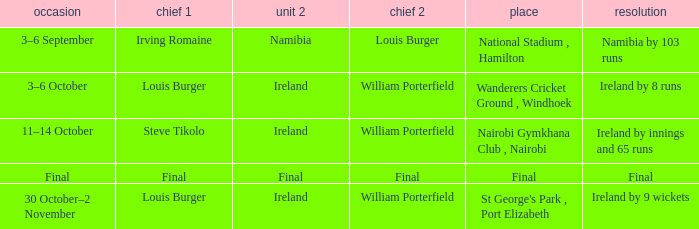Which Result has a Captain 2 of louis burger? Namibia by 103 runs. Could you help me parse every detail presented in this table? {'header': ['occasion', 'chief 1', 'unit 2', 'chief 2', 'place', 'resolution'], 'rows': [['3–6 September', 'Irving Romaine', 'Namibia', 'Louis Burger', 'National Stadium , Hamilton', 'Namibia by 103 runs'], ['3–6 October', 'Louis Burger', 'Ireland', 'William Porterfield', 'Wanderers Cricket Ground , Windhoek', 'Ireland by 8 runs'], ['11–14 October', 'Steve Tikolo', 'Ireland', 'William Porterfield', 'Nairobi Gymkhana Club , Nairobi', 'Ireland by innings and 65 runs'], ['Final', 'Final', 'Final', 'Final', 'Final', 'Final'], ['30 October–2 November', 'Louis Burger', 'Ireland', 'William Porterfield', "St George's Park , Port Elizabeth", 'Ireland by 9 wickets']]} 